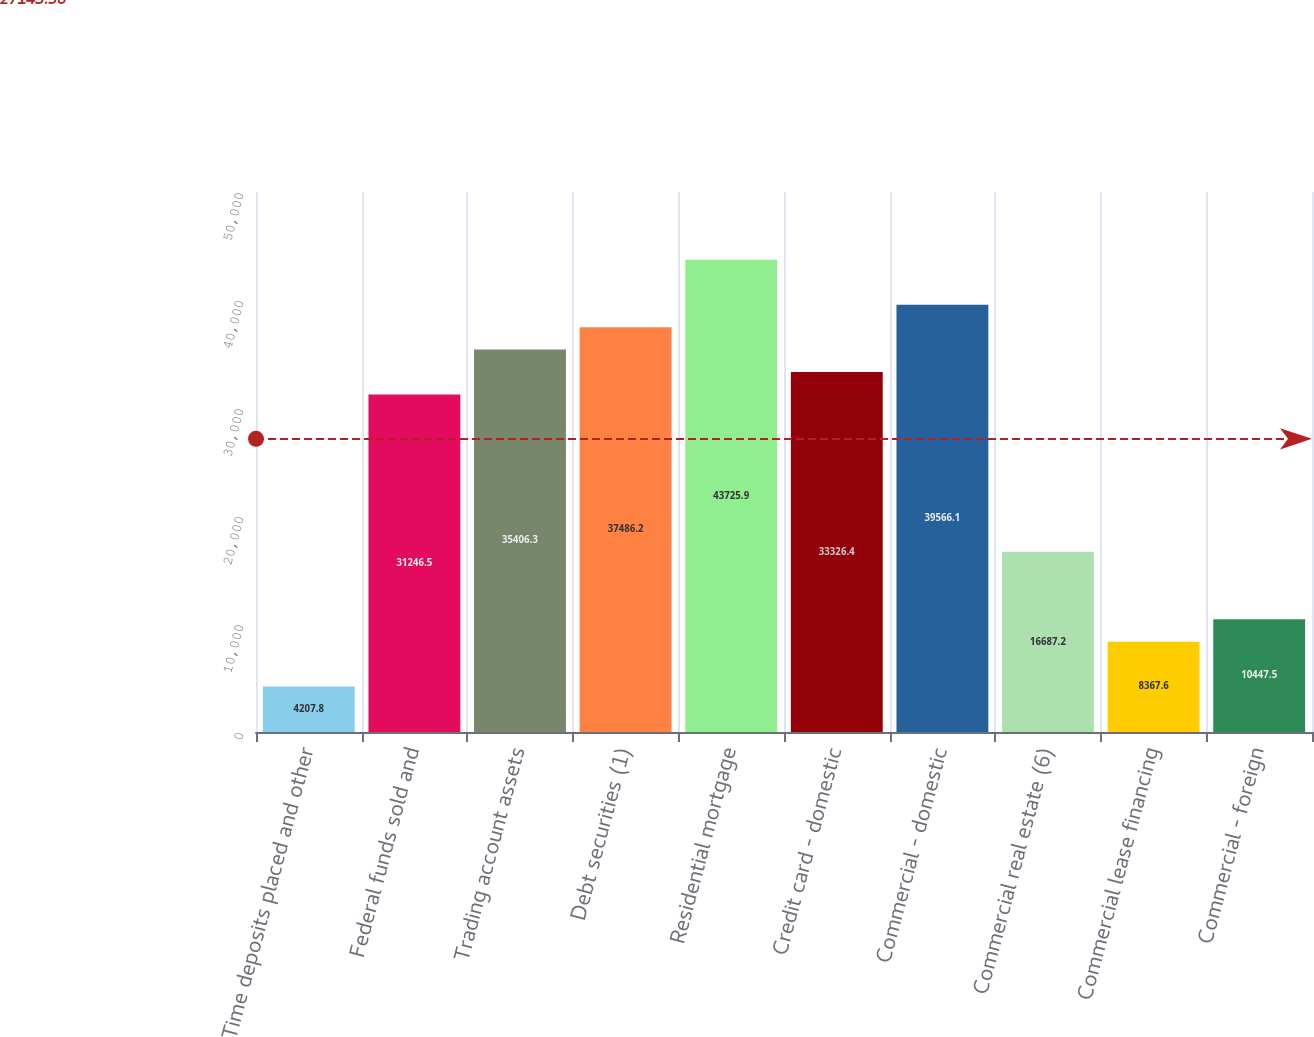Convert chart. <chart><loc_0><loc_0><loc_500><loc_500><bar_chart><fcel>Time deposits placed and other<fcel>Federal funds sold and<fcel>Trading account assets<fcel>Debt securities (1)<fcel>Residential mortgage<fcel>Credit card - domestic<fcel>Commercial - domestic<fcel>Commercial real estate (6)<fcel>Commercial lease financing<fcel>Commercial - foreign<nl><fcel>4207.8<fcel>31246.5<fcel>35406.3<fcel>37486.2<fcel>43725.9<fcel>33326.4<fcel>39566.1<fcel>16687.2<fcel>8367.6<fcel>10447.5<nl></chart> 